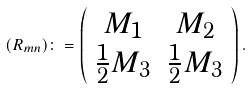<formula> <loc_0><loc_0><loc_500><loc_500>( R _ { m n } ) \colon = \left ( \begin{array} { c c } M _ { 1 } & M _ { 2 } \\ \frac { 1 } { 2 } M _ { 3 } & \frac { 1 } { 2 } M _ { 3 } \end{array} \right ) .</formula> 